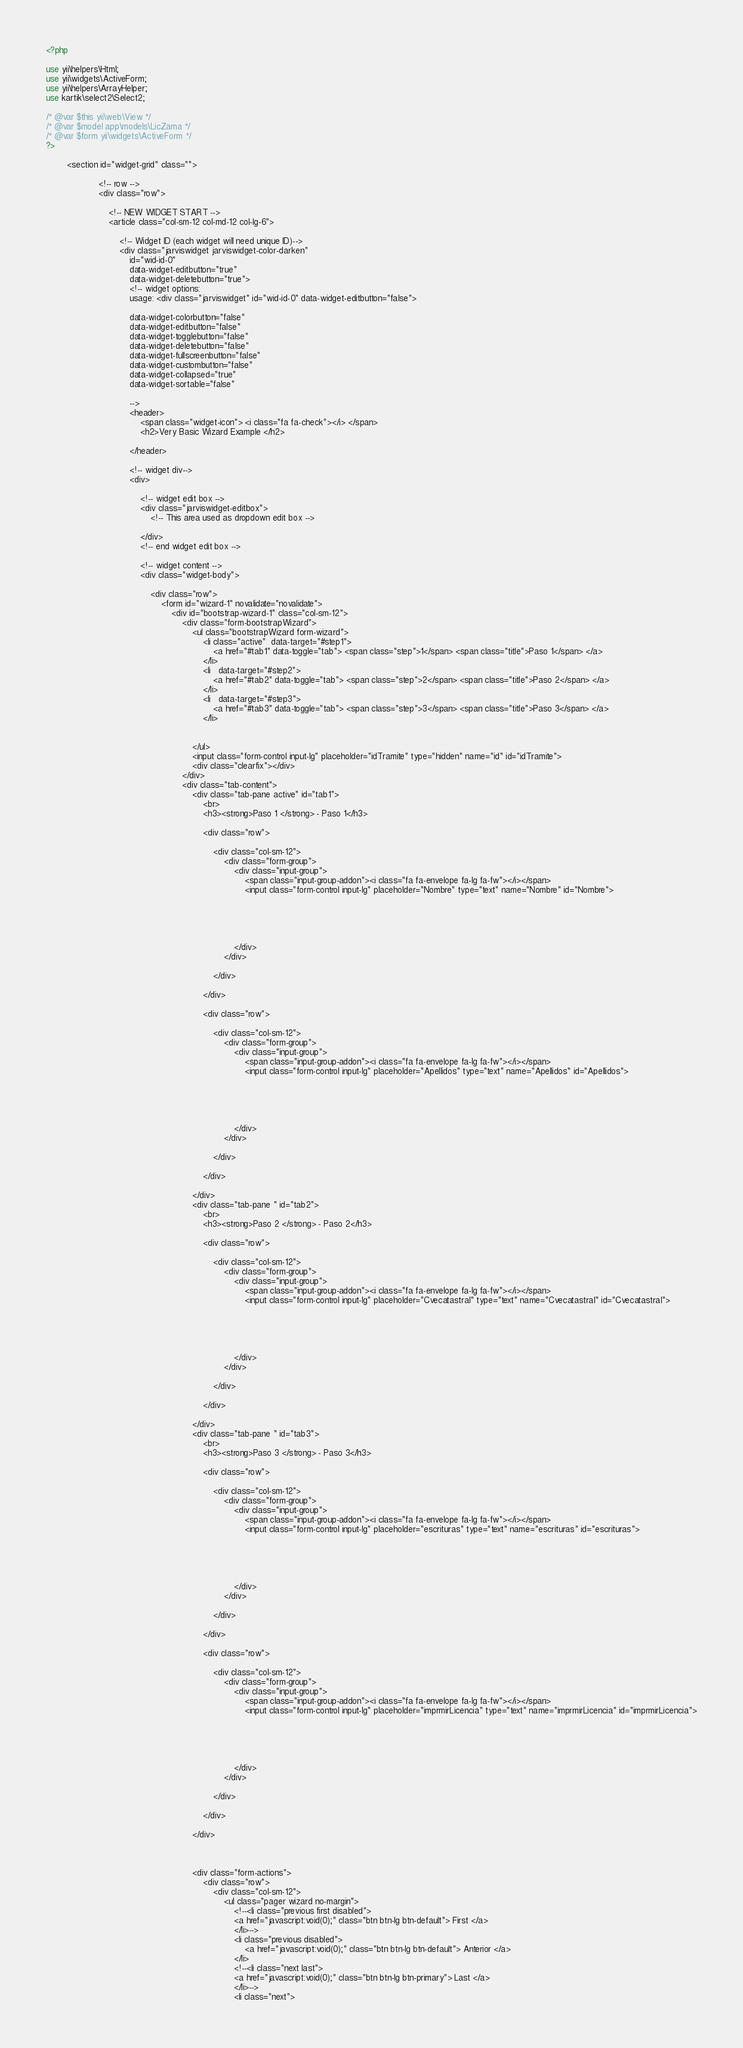Convert code to text. <code><loc_0><loc_0><loc_500><loc_500><_PHP_><?php

use yii\helpers\Html;
use yii\widgets\ActiveForm;
use yii\helpers\ArrayHelper;
use kartik\select2\Select2;

/* @var $this yii\web\View */
/* @var $model app\models\LicZama */
/* @var $form yii\widgets\ActiveForm */
?>

		<section id="widget-grid" class="">
                
                    <!-- row -->
                    <div class="row">
                
                        <!-- NEW WIDGET START -->
                        <article class="col-sm-12 col-md-12 col-lg-6">
                
                            <!-- Widget ID (each widget will need unique ID)-->
                            <div class="jarviswidget jarviswidget-color-darken" 
                                id="wid-id-0" 
                                data-widget-editbutton="true" 
                                data-widget-deletebutton="true">
                                <!-- widget options:
                                usage: <div class="jarviswidget" id="wid-id-0" data-widget-editbutton="false">
                
                                data-widget-colorbutton="false"
                                data-widget-editbutton="false"
                                data-widget-togglebutton="false"
                                data-widget-deletebutton="false"
                                data-widget-fullscreenbutton="false"
                                data-widget-custombutton="false"
                                data-widget-collapsed="true"
                                data-widget-sortable="false"
                
                                -->
                                <header>
                                    <span class="widget-icon"> <i class="fa fa-check"></i> </span>
                                    <h2>Very Basic Wizard Example </h2>
                
                                </header>
                
                                <!-- widget div-->
                                <div>
                
                                    <!-- widget edit box -->
                                    <div class="jarviswidget-editbox">
                                        <!-- This area used as dropdown edit box -->
                
                                    </div>
                                    <!-- end widget edit box -->
                
                                    <!-- widget content -->
                                    <div class="widget-body">
                
                                        <div class="row">
                                            <form id="wizard-1" novalidate="novalidate">
                                                <div id="bootstrap-wizard-1" class="col-sm-12">
                                                    <div class="form-bootstrapWizard">
                                                        <ul class="bootstrapWizard form-wizard">
                                                            <li class="active"  data-target="#step1">
                                                                <a href="#tab1" data-toggle="tab"> <span class="step">1</span> <span class="title">Paso 1</span> </a>
                                                            </li>
                                                            <li   data-target="#step2">
                                                                <a href="#tab2" data-toggle="tab"> <span class="step">2</span> <span class="title">Paso 2</span> </a>
                                                            </li>
                                                            <li   data-target="#step3">
                                                                <a href="#tab3" data-toggle="tab"> <span class="step">3</span> <span class="title">Paso 3</span> </a>
                                                            </li>
                                                           
                                                            
                                                        </ul>
                                                        <input class="form-control input-lg" placeholder="idTramite" type="hidden" name="id" id="idTramite">
                                                        <div class="clearfix"></div>
                                                    </div>
                                                    <div class="tab-content">
                                                        <div class="tab-pane active" id="tab1">
                                                            <br>
                                                            <h3><strong>Paso 1 </strong> - Paso 1</h3>

                                                            <div class="row">
                
                                                                <div class="col-sm-12">
                                                                    <div class="form-group">
                                                                        <div class="input-group">
                                                                            <span class="input-group-addon"><i class="fa fa-envelope fa-lg fa-fw"></i></span>
                                                                            <input class="form-control input-lg" placeholder="Nombre" type="text" name="Nombre" id="Nombre">


                                                                           

                
                                                                        </div>
                                                                    </div>
                
                                                                </div>
                
                                                            </div>

                                                            <div class="row">
                
                                                                <div class="col-sm-12">
                                                                    <div class="form-group">
                                                                        <div class="input-group">
                                                                            <span class="input-group-addon"><i class="fa fa-envelope fa-lg fa-fw"></i></span>
                                                                            <input class="form-control input-lg" placeholder="Apellidos" type="text" name="Apellidos" id="Apellidos">


                                                                           

                
                                                                        </div>
                                                                    </div>
                
                                                                </div>
                
                                                            </div>

                                                        </div>
                                                        <div class="tab-pane " id="tab2">
                                                            <br>
                                                            <h3><strong>Paso 2 </strong> - Paso 2</h3>

                                                            <div class="row">
                
                                                                <div class="col-sm-12">
                                                                    <div class="form-group">
                                                                        <div class="input-group">
                                                                            <span class="input-group-addon"><i class="fa fa-envelope fa-lg fa-fw"></i></span>
                                                                            <input class="form-control input-lg" placeholder="Cvecatastral" type="text" name="Cvecatastral" id="Cvecatastral">


                                                                           

                
                                                                        </div>
                                                                    </div>
                
                                                                </div>
                
                                                            </div>

                                                        </div>
                                                        <div class="tab-pane " id="tab3">
                                                            <br>
                                                            <h3><strong>Paso 3 </strong> - Paso 3</h3>

                                                            <div class="row">
                
                                                                <div class="col-sm-12">
                                                                    <div class="form-group">
                                                                        <div class="input-group">
                                                                            <span class="input-group-addon"><i class="fa fa-envelope fa-lg fa-fw"></i></span>
                                                                            <input class="form-control input-lg" placeholder="escrituras" type="text" name="escrituras" id="escrituras">


                                                                           

                
                                                                        </div>
                                                                    </div>
                
                                                                </div>
                
                                                            </div>

                                                            <div class="row">
                
                                                                <div class="col-sm-12">
                                                                    <div class="form-group">
                                                                        <div class="input-group">
                                                                            <span class="input-group-addon"><i class="fa fa-envelope fa-lg fa-fw"></i></span>
                                                                            <input class="form-control input-lg" placeholder="imprmirLicencia" type="text" name="imprmirLicencia" id="imprmirLicencia">


                                                                           

                
                                                                        </div>
                                                                    </div>
                
                                                                </div>
                
                                                            </div>

                                                        </div>

                                                  
                
                                                        <div class="form-actions">
                                                            <div class="row">
                                                                <div class="col-sm-12">
                                                                    <ul class="pager wizard no-margin">
                                                                        <!--<li class="previous first disabled">
                                                                        <a href="javascript:void(0);" class="btn btn-lg btn-default"> First </a>
                                                                        </li>-->
                                                                        <li class="previous disabled">
                                                                            <a href="javascript:void(0);" class="btn btn-lg btn-default"> Anterior </a>
                                                                        </li>
                                                                        <!--<li class="next last">
                                                                        <a href="javascript:void(0);" class="btn btn-lg btn-primary"> Last </a>
                                                                        </li>-->
                                                                        <li class="next"></code> 